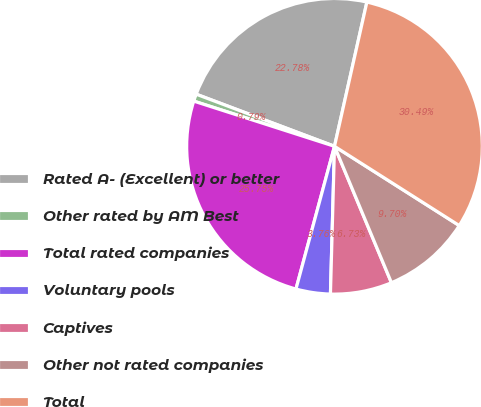<chart> <loc_0><loc_0><loc_500><loc_500><pie_chart><fcel>Rated A- (Excellent) or better<fcel>Other rated by AM Best<fcel>Total rated companies<fcel>Voluntary pools<fcel>Captives<fcel>Other not rated companies<fcel>Total<nl><fcel>22.78%<fcel>0.79%<fcel>25.75%<fcel>3.76%<fcel>6.73%<fcel>9.7%<fcel>30.49%<nl></chart> 